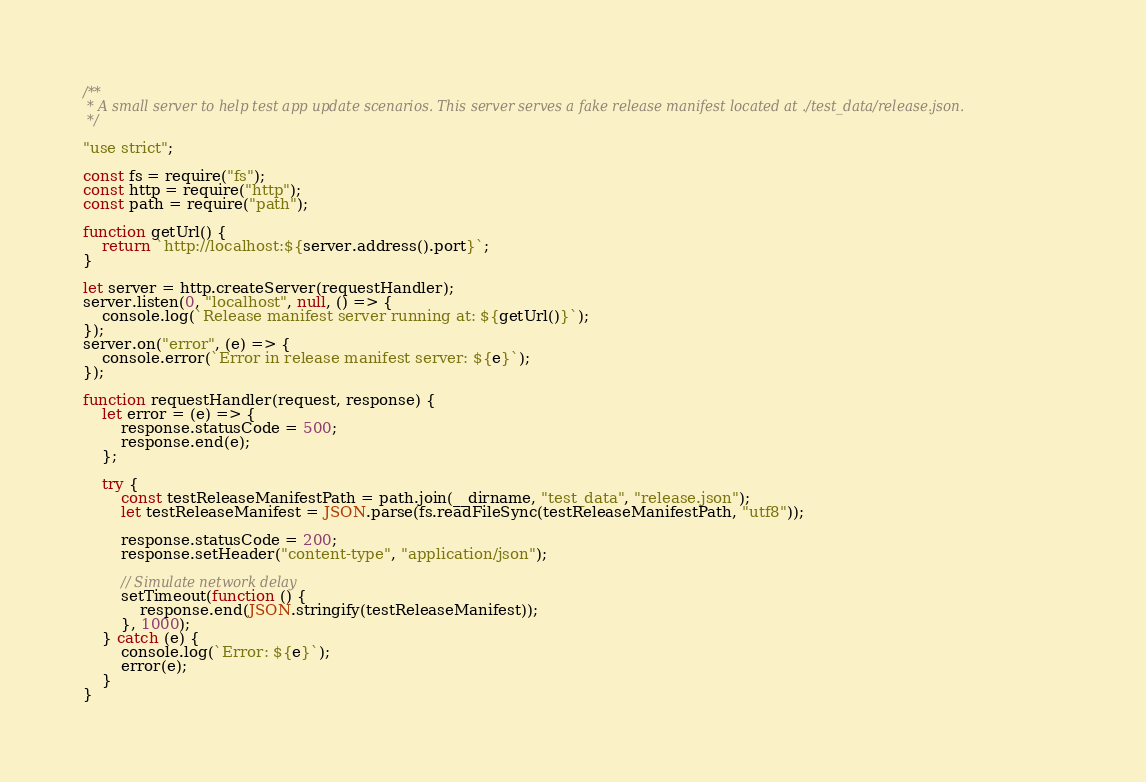Convert code to text. <code><loc_0><loc_0><loc_500><loc_500><_JavaScript_>/**
 * A small server to help test app update scenarios. This server serves a fake release manifest located at ./test_data/release.json.
 */

"use strict";

const fs = require("fs");
const http = require("http");
const path = require("path");

function getUrl() {
    return `http://localhost:${server.address().port}`;
}

let server = http.createServer(requestHandler);
server.listen(0, "localhost", null, () => {
    console.log(`Release manifest server running at: ${getUrl()}`);
});
server.on("error", (e) => {
    console.error(`Error in release manifest server: ${e}`);
});

function requestHandler(request, response) {
    let error = (e) => {
        response.statusCode = 500;
        response.end(e);
    };

    try {
        const testReleaseManifestPath = path.join(__dirname, "test_data", "release.json");
        let testReleaseManifest = JSON.parse(fs.readFileSync(testReleaseManifestPath, "utf8"));

        response.statusCode = 200;
        response.setHeader("content-type", "application/json");

        // Simulate network delay
        setTimeout(function () {
            response.end(JSON.stringify(testReleaseManifest));
        }, 1000);
    } catch (e) {
        console.log(`Error: ${e}`);
        error(e);
    }
}
</code> 